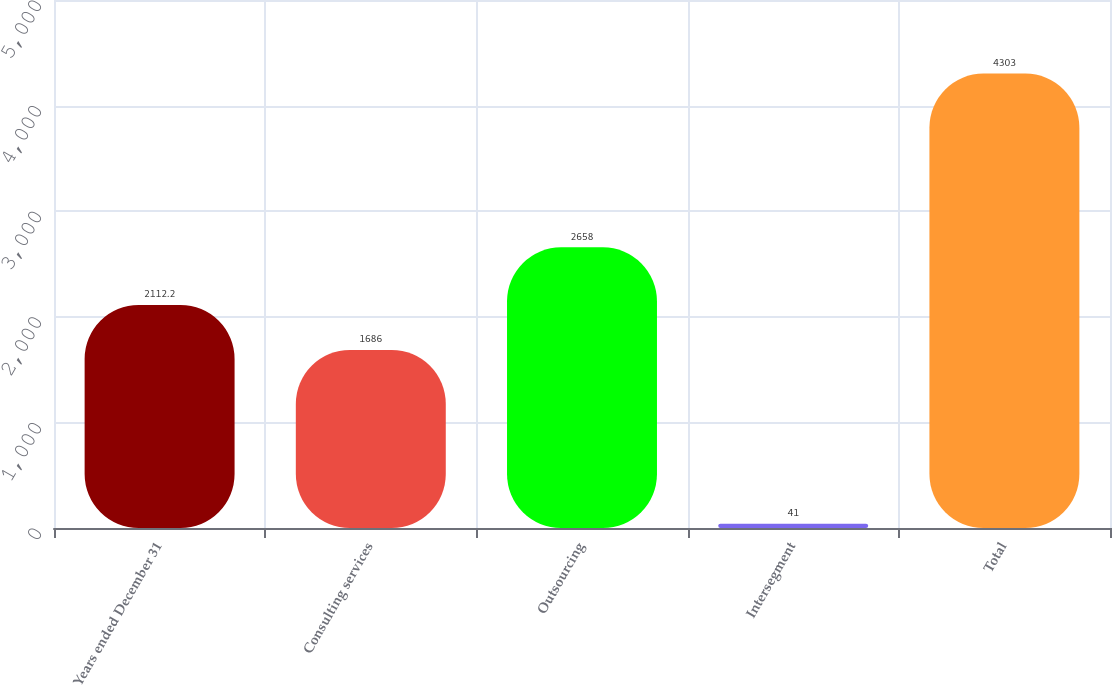Convert chart to OTSL. <chart><loc_0><loc_0><loc_500><loc_500><bar_chart><fcel>Years ended December 31<fcel>Consulting services<fcel>Outsourcing<fcel>Intersegment<fcel>Total<nl><fcel>2112.2<fcel>1686<fcel>2658<fcel>41<fcel>4303<nl></chart> 